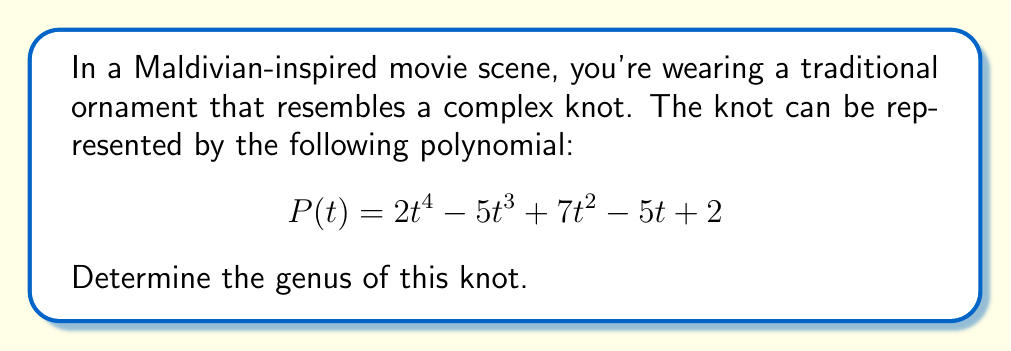Help me with this question. To find the genus of the knot, we'll follow these steps:

1) First, recall that for an alternating knot, the genus $g$ is related to the degree of its Alexander polynomial $\Delta(t)$ by the formula:

   $$g = \frac{1}{2}(\text{deg}(\Delta(t)) - 1 + 1)$$

   where $\text{deg}(\Delta(t))$ is the degree of the Alexander polynomial.

2) In this case, we're given a polynomial $P(t)$, which we'll assume is the Alexander polynomial of the knot.

3) The degree of $P(t)$ is 4, as the highest power of $t$ is $t^4$.

4) Substituting into the formula:

   $$g = \frac{1}{2}(4 - 1 + 1) = \frac{1}{2}(4) = 2$$

5) Therefore, the genus of the knot is 2.

Note: This calculation assumes that the given polynomial is indeed the Alexander polynomial of an alternating knot. In reality, determining whether a given polynomial is a valid Alexander polynomial and whether the corresponding knot is alternating would require additional analysis.
Answer: 2 